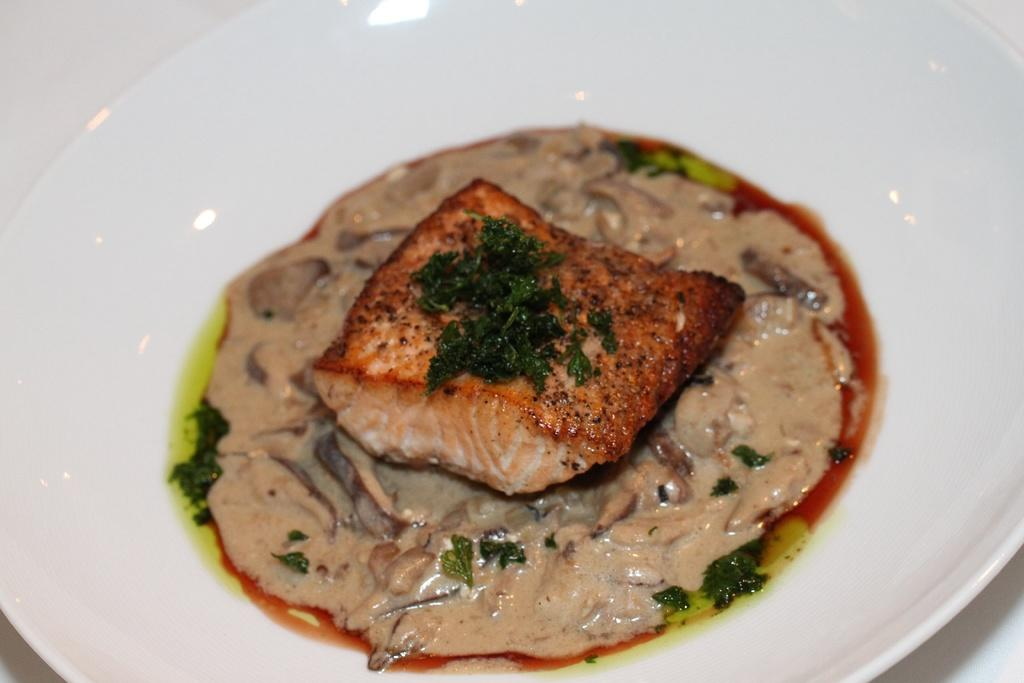What is in the bowl that is visible in the image? There is food placed in a bowl in the image. Where is the bowl located in the image? The bowl is kept on a surface in the image. Can you recall the memory of the geese flying in harmony in the image? There are no geese or any reference to harmony in the image; it only features a bowl of food placed on a surface. 